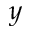<formula> <loc_0><loc_0><loc_500><loc_500>y</formula> 